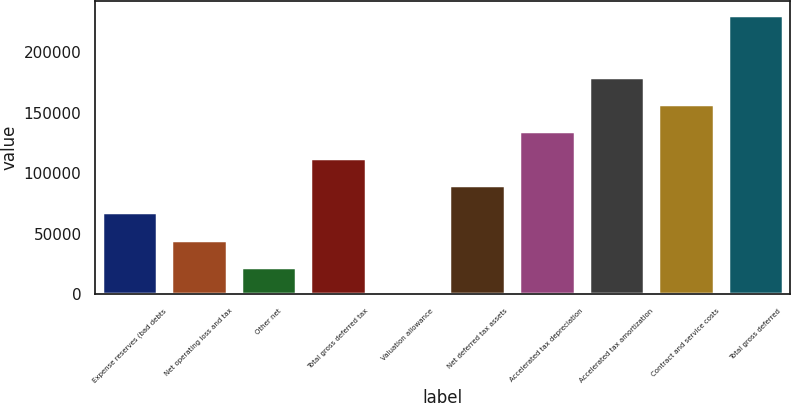Convert chart to OTSL. <chart><loc_0><loc_0><loc_500><loc_500><bar_chart><fcel>Expense reserves (bad debts<fcel>Net operating loss and tax<fcel>Other net<fcel>Total gross deferred tax<fcel>Valuation allowance<fcel>Net deferred tax assets<fcel>Accelerated tax depreciation<fcel>Accelerated tax amortization<fcel>Contract and service costs<fcel>Total gross deferred<nl><fcel>67687.1<fcel>45296.4<fcel>22905.7<fcel>112468<fcel>515<fcel>90077.8<fcel>134859<fcel>179641<fcel>157250<fcel>230694<nl></chart> 